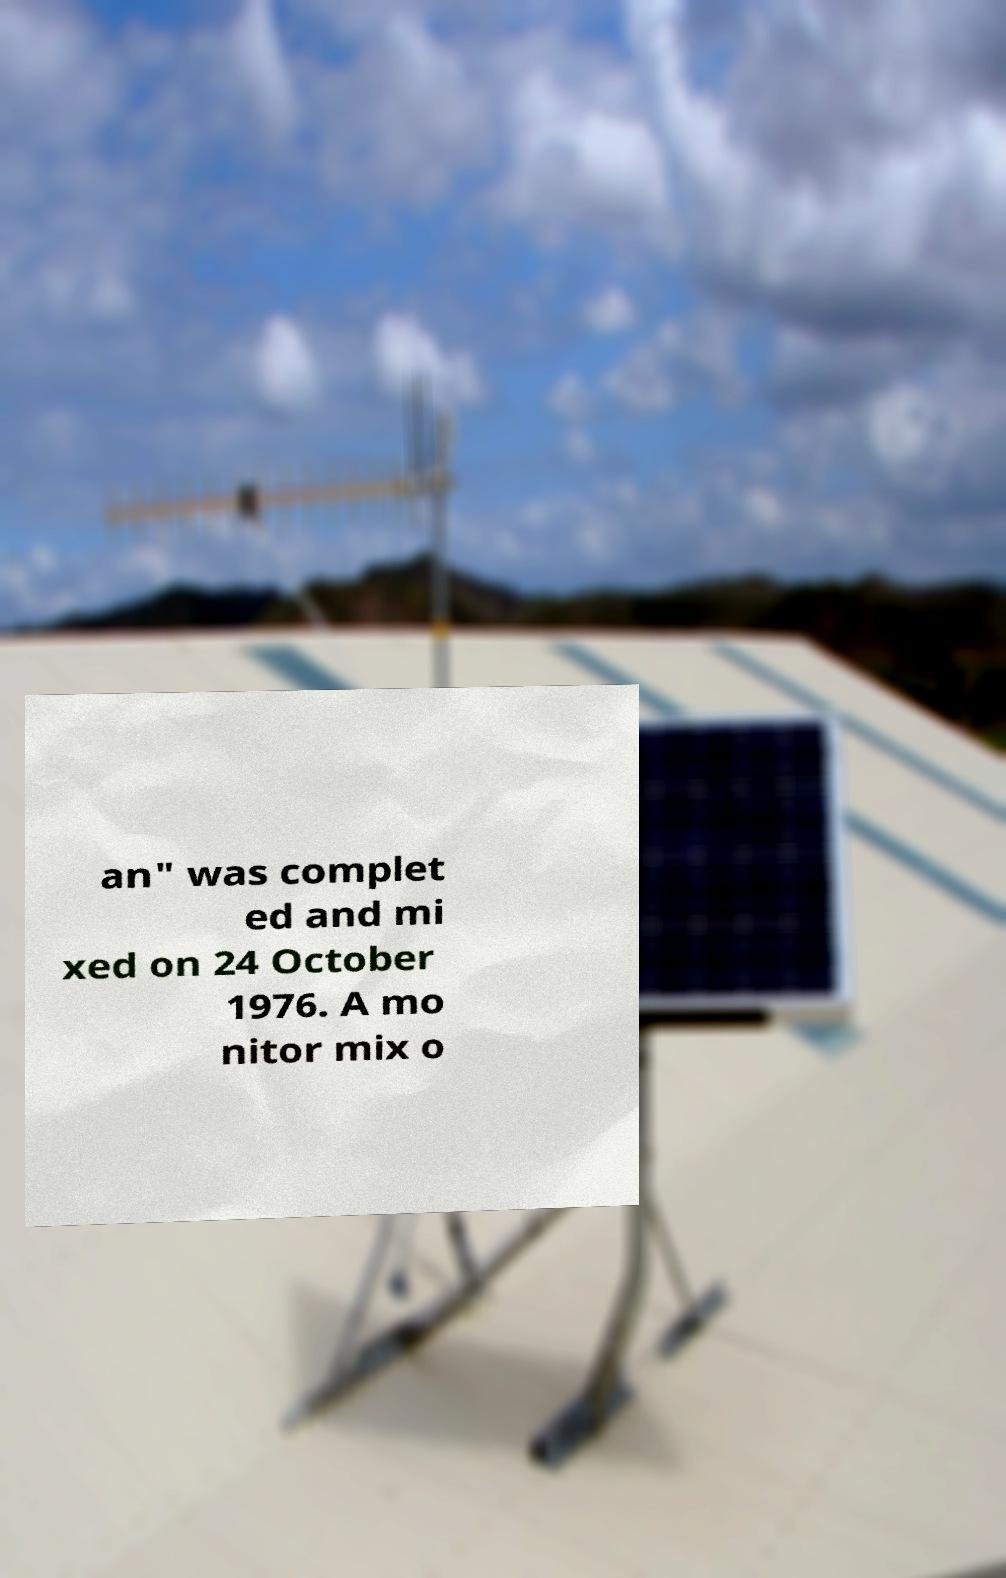What messages or text are displayed in this image? I need them in a readable, typed format. an" was complet ed and mi xed on 24 October 1976. A mo nitor mix o 